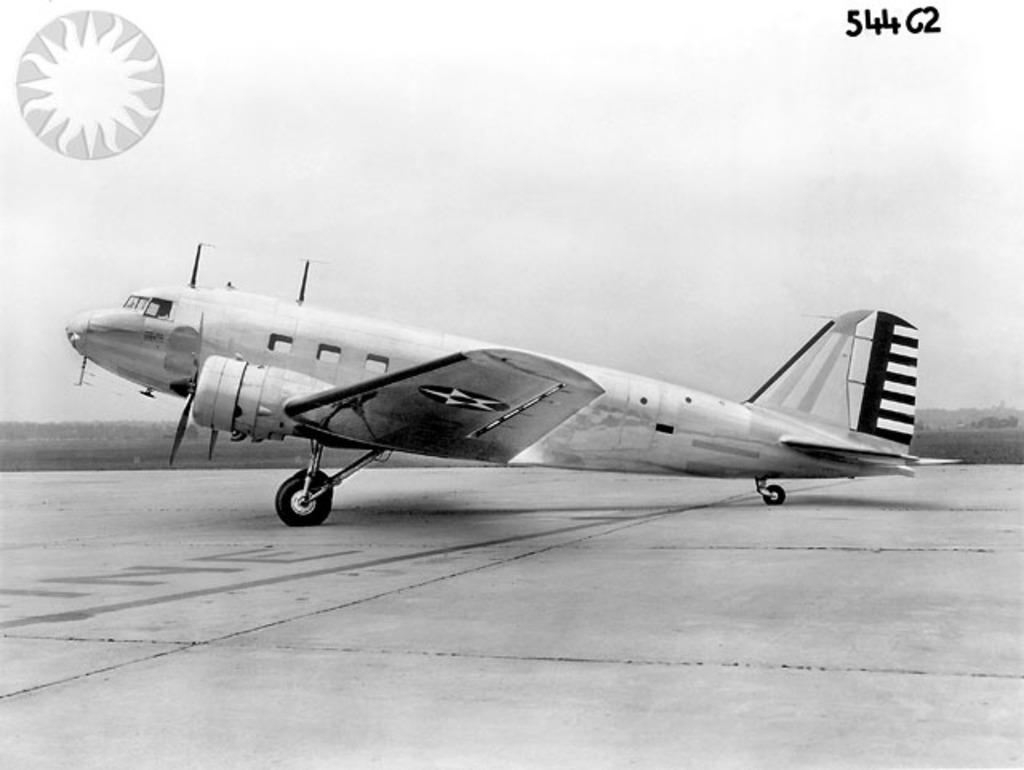What is the color scheme of the image? The image is black and white. What can be seen on the runway in the image? There is an airplane on the runway in the image. Where is the logo located in the image? The logo is in the top left of the image. What is visible in the background of the image? The sky is visible in the background of the image. What type of country is depicted in the image? There is no country depicted in the image; it features an airplane on a runway with a black and white color scheme. What kind of attraction can be seen in the image? There is no attraction present in the image; it only shows an airplane on a runway, a logo, and the sky. 